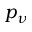<formula> <loc_0><loc_0><loc_500><loc_500>p _ { \nu }</formula> 